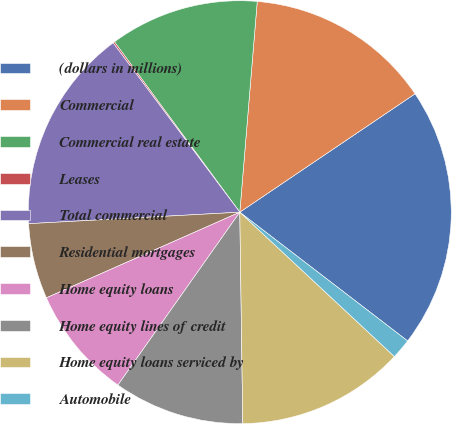Convert chart. <chart><loc_0><loc_0><loc_500><loc_500><pie_chart><fcel>(dollars in millions)<fcel>Commercial<fcel>Commercial real estate<fcel>Leases<fcel>Total commercial<fcel>Residential mortgages<fcel>Home equity loans<fcel>Home equity lines of credit<fcel>Home equity loans serviced by<fcel>Automobile<nl><fcel>19.87%<fcel>14.23%<fcel>11.41%<fcel>0.13%<fcel>15.64%<fcel>5.77%<fcel>8.59%<fcel>10.0%<fcel>12.82%<fcel>1.54%<nl></chart> 